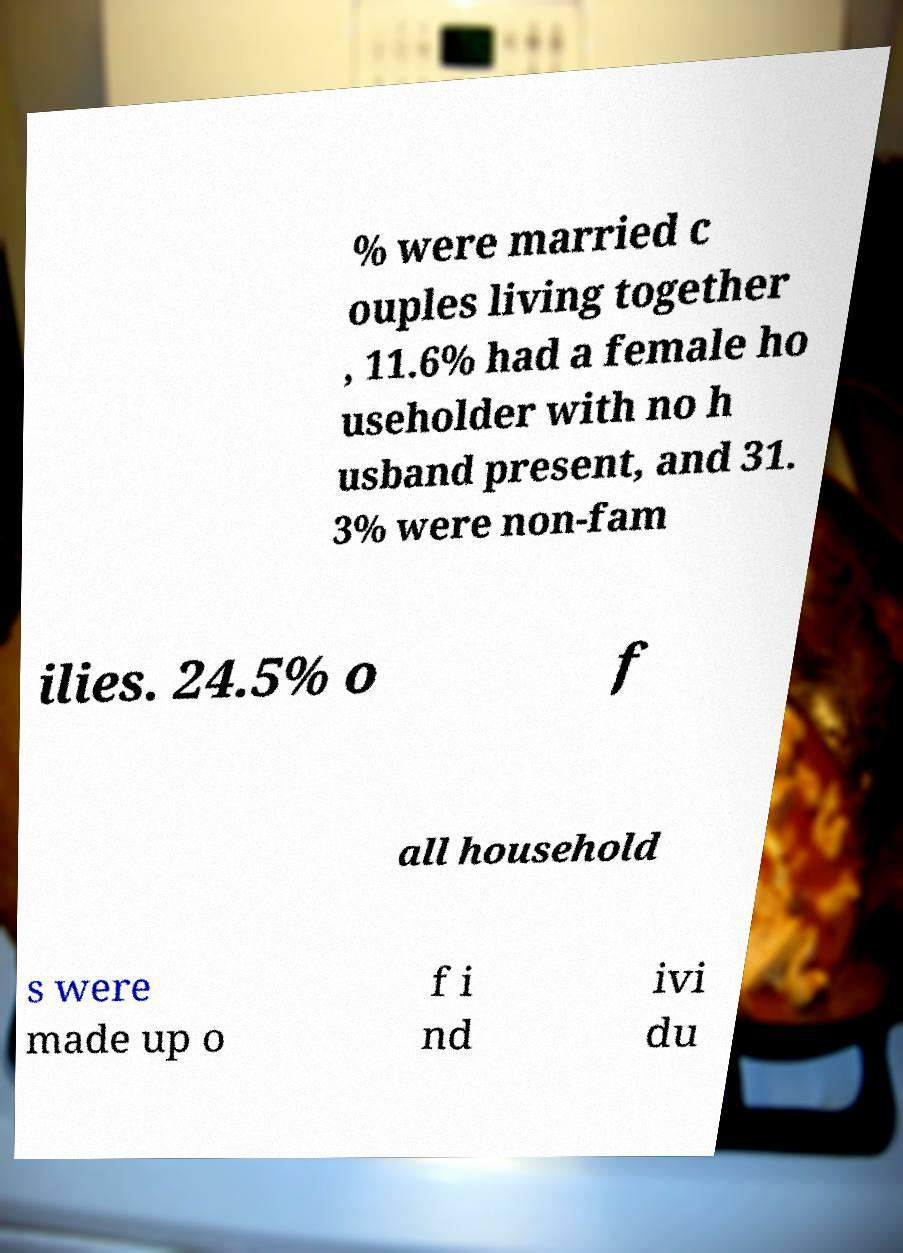I need the written content from this picture converted into text. Can you do that? % were married c ouples living together , 11.6% had a female ho useholder with no h usband present, and 31. 3% were non-fam ilies. 24.5% o f all household s were made up o f i nd ivi du 